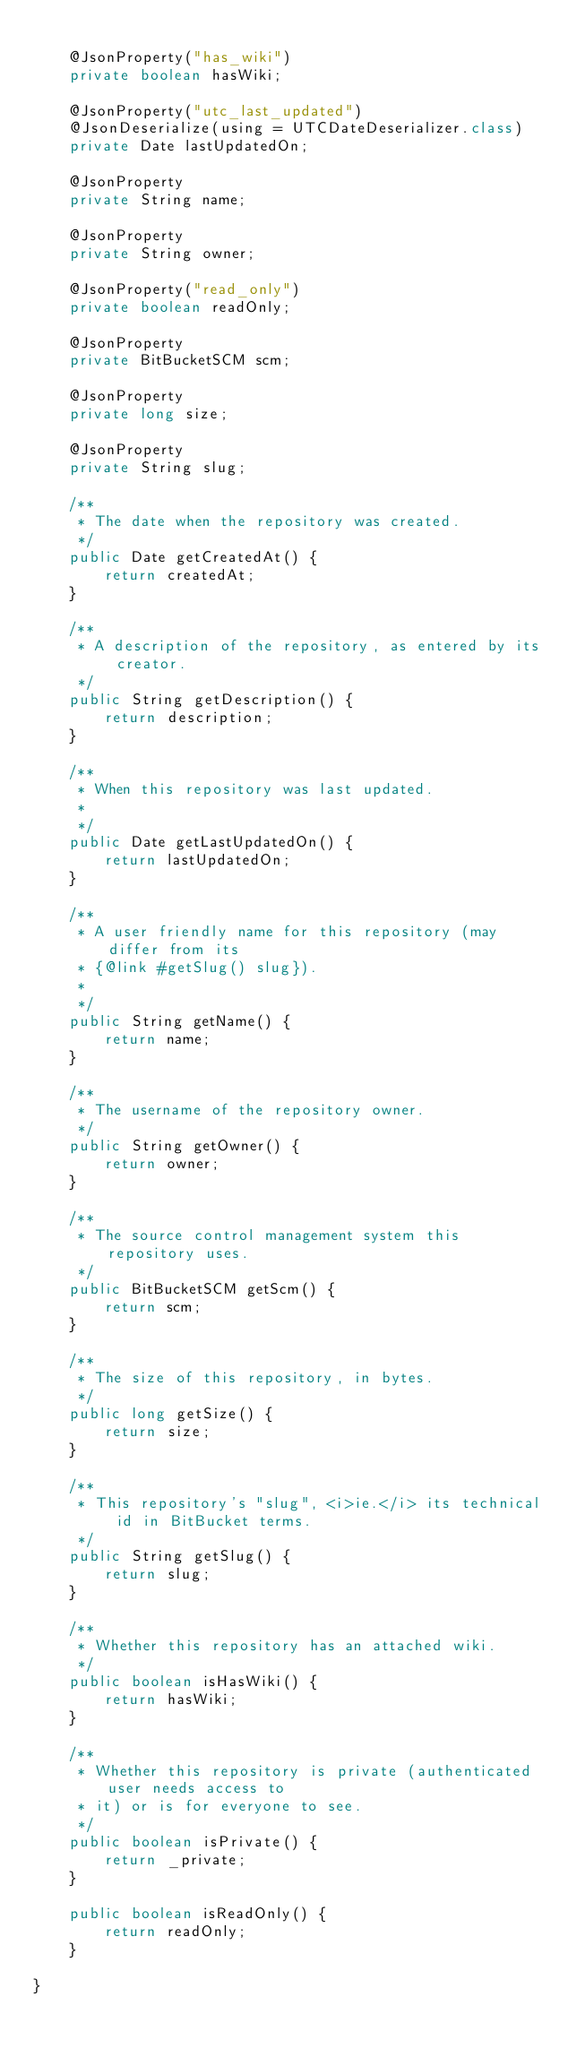<code> <loc_0><loc_0><loc_500><loc_500><_Java_>
    @JsonProperty("has_wiki")
    private boolean hasWiki;

    @JsonProperty("utc_last_updated")
    @JsonDeserialize(using = UTCDateDeserializer.class)
    private Date lastUpdatedOn;

    @JsonProperty
    private String name;

    @JsonProperty
    private String owner;

    @JsonProperty("read_only")
    private boolean readOnly;

    @JsonProperty
    private BitBucketSCM scm;

    @JsonProperty
    private long size;

    @JsonProperty
    private String slug;

    /**
     * The date when the repository was created.
     */
    public Date getCreatedAt() {
        return createdAt;
    }

    /**
     * A description of the repository, as entered by its creator.
     */
    public String getDescription() {
        return description;
    }

    /**
     * When this repository was last updated.
     * 
     */
    public Date getLastUpdatedOn() {
        return lastUpdatedOn;
    }

    /**
     * A user friendly name for this repository (may differ from its
     * {@link #getSlug() slug}).
     * 
     */
    public String getName() {
        return name;
    }

    /**
     * The username of the repository owner.
     */
    public String getOwner() {
        return owner;
    }

    /**
     * The source control management system this repository uses.
     */
    public BitBucketSCM getScm() {
        return scm;
    }

    /**
     * The size of this repository, in bytes.
     */
    public long getSize() {
        return size;
    }

    /**
     * This repository's "slug", <i>ie.</i> its technical id in BitBucket terms.
     */
    public String getSlug() {
        return slug;
    }

    /**
     * Whether this repository has an attached wiki.
     */
    public boolean isHasWiki() {
        return hasWiki;
    }

    /**
     * Whether this repository is private (authenticated user needs access to
     * it) or is for everyone to see.
     */
    public boolean isPrivate() {
        return _private;
    }

    public boolean isReadOnly() {
        return readOnly;
    }

}
</code> 